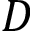<formula> <loc_0><loc_0><loc_500><loc_500>D</formula> 